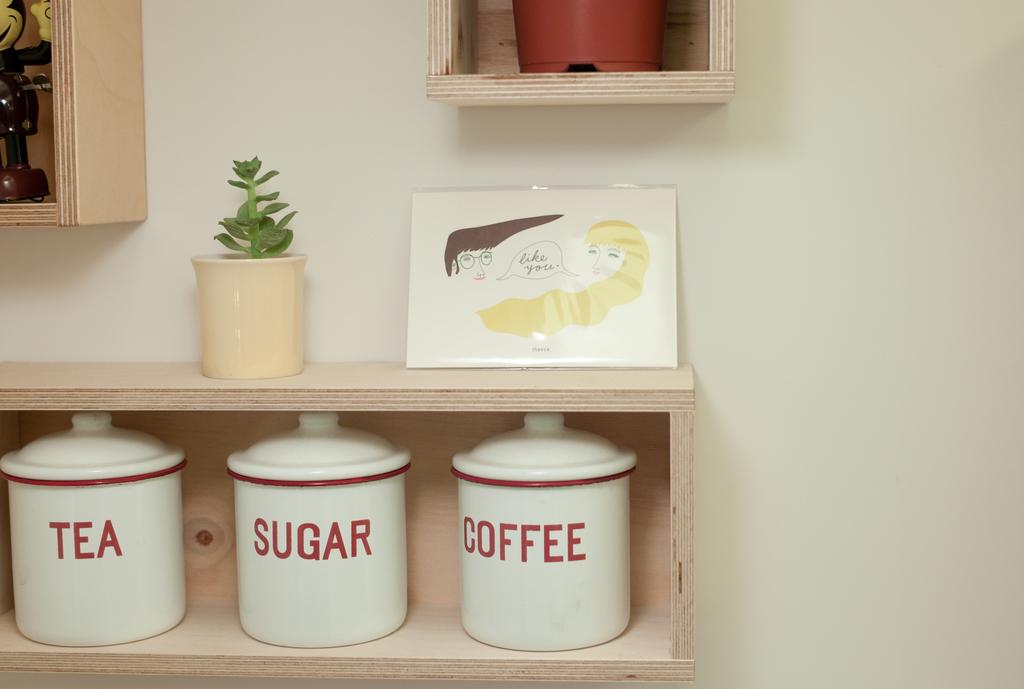What is in the jars?
Make the answer very short. Tea sugar coffee. What does the picture above the jars say?
Make the answer very short. Like you. 